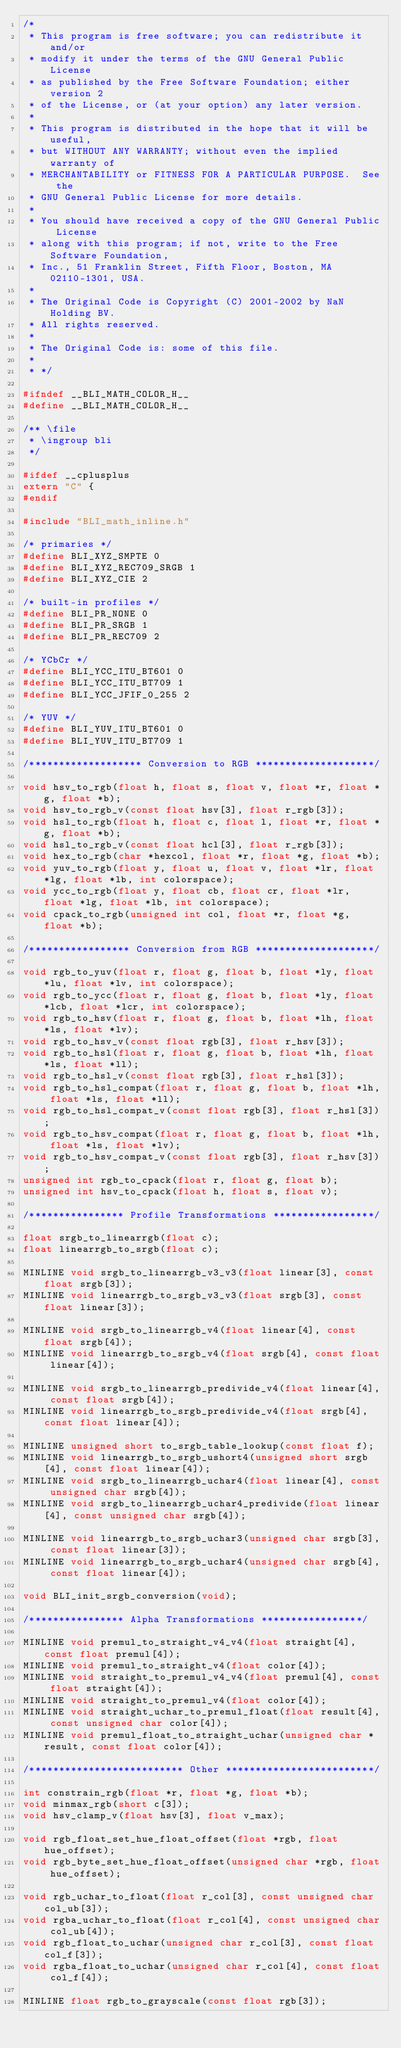Convert code to text. <code><loc_0><loc_0><loc_500><loc_500><_C_>/*
 * This program is free software; you can redistribute it and/or
 * modify it under the terms of the GNU General Public License
 * as published by the Free Software Foundation; either version 2
 * of the License, or (at your option) any later version.
 *
 * This program is distributed in the hope that it will be useful,
 * but WITHOUT ANY WARRANTY; without even the implied warranty of
 * MERCHANTABILITY or FITNESS FOR A PARTICULAR PURPOSE.  See the
 * GNU General Public License for more details.
 *
 * You should have received a copy of the GNU General Public License
 * along with this program; if not, write to the Free Software Foundation,
 * Inc., 51 Franklin Street, Fifth Floor, Boston, MA 02110-1301, USA.
 *
 * The Original Code is Copyright (C) 2001-2002 by NaN Holding BV.
 * All rights reserved.
 *
 * The Original Code is: some of this file.
 *
 * */

#ifndef __BLI_MATH_COLOR_H__
#define __BLI_MATH_COLOR_H__

/** \file
 * \ingroup bli
 */

#ifdef __cplusplus
extern "C" {
#endif

#include "BLI_math_inline.h"

/* primaries */
#define BLI_XYZ_SMPTE 0
#define BLI_XYZ_REC709_SRGB 1
#define BLI_XYZ_CIE 2

/* built-in profiles */
#define BLI_PR_NONE 0
#define BLI_PR_SRGB 1
#define BLI_PR_REC709 2

/* YCbCr */
#define BLI_YCC_ITU_BT601 0
#define BLI_YCC_ITU_BT709 1
#define BLI_YCC_JFIF_0_255 2

/* YUV */
#define BLI_YUV_ITU_BT601 0
#define BLI_YUV_ITU_BT709 1

/******************* Conversion to RGB ********************/

void hsv_to_rgb(float h, float s, float v, float *r, float *g, float *b);
void hsv_to_rgb_v(const float hsv[3], float r_rgb[3]);
void hsl_to_rgb(float h, float c, float l, float *r, float *g, float *b);
void hsl_to_rgb_v(const float hcl[3], float r_rgb[3]);
void hex_to_rgb(char *hexcol, float *r, float *g, float *b);
void yuv_to_rgb(float y, float u, float v, float *lr, float *lg, float *lb, int colorspace);
void ycc_to_rgb(float y, float cb, float cr, float *lr, float *lg, float *lb, int colorspace);
void cpack_to_rgb(unsigned int col, float *r, float *g, float *b);

/***************** Conversion from RGB ********************/

void rgb_to_yuv(float r, float g, float b, float *ly, float *lu, float *lv, int colorspace);
void rgb_to_ycc(float r, float g, float b, float *ly, float *lcb, float *lcr, int colorspace);
void rgb_to_hsv(float r, float g, float b, float *lh, float *ls, float *lv);
void rgb_to_hsv_v(const float rgb[3], float r_hsv[3]);
void rgb_to_hsl(float r, float g, float b, float *lh, float *ls, float *ll);
void rgb_to_hsl_v(const float rgb[3], float r_hsl[3]);
void rgb_to_hsl_compat(float r, float g, float b, float *lh, float *ls, float *ll);
void rgb_to_hsl_compat_v(const float rgb[3], float r_hsl[3]);
void rgb_to_hsv_compat(float r, float g, float b, float *lh, float *ls, float *lv);
void rgb_to_hsv_compat_v(const float rgb[3], float r_hsv[3]);
unsigned int rgb_to_cpack(float r, float g, float b);
unsigned int hsv_to_cpack(float h, float s, float v);

/**************** Profile Transformations *****************/

float srgb_to_linearrgb(float c);
float linearrgb_to_srgb(float c);

MINLINE void srgb_to_linearrgb_v3_v3(float linear[3], const float srgb[3]);
MINLINE void linearrgb_to_srgb_v3_v3(float srgb[3], const float linear[3]);

MINLINE void srgb_to_linearrgb_v4(float linear[4], const float srgb[4]);
MINLINE void linearrgb_to_srgb_v4(float srgb[4], const float linear[4]);

MINLINE void srgb_to_linearrgb_predivide_v4(float linear[4], const float srgb[4]);
MINLINE void linearrgb_to_srgb_predivide_v4(float srgb[4], const float linear[4]);

MINLINE unsigned short to_srgb_table_lookup(const float f);
MINLINE void linearrgb_to_srgb_ushort4(unsigned short srgb[4], const float linear[4]);
MINLINE void srgb_to_linearrgb_uchar4(float linear[4], const unsigned char srgb[4]);
MINLINE void srgb_to_linearrgb_uchar4_predivide(float linear[4], const unsigned char srgb[4]);

MINLINE void linearrgb_to_srgb_uchar3(unsigned char srgb[3], const float linear[3]);
MINLINE void linearrgb_to_srgb_uchar4(unsigned char srgb[4], const float linear[4]);

void BLI_init_srgb_conversion(void);

/**************** Alpha Transformations *****************/

MINLINE void premul_to_straight_v4_v4(float straight[4], const float premul[4]);
MINLINE void premul_to_straight_v4(float color[4]);
MINLINE void straight_to_premul_v4_v4(float premul[4], const float straight[4]);
MINLINE void straight_to_premul_v4(float color[4]);
MINLINE void straight_uchar_to_premul_float(float result[4], const unsigned char color[4]);
MINLINE void premul_float_to_straight_uchar(unsigned char *result, const float color[4]);

/************************** Other *************************/

int constrain_rgb(float *r, float *g, float *b);
void minmax_rgb(short c[3]);
void hsv_clamp_v(float hsv[3], float v_max);

void rgb_float_set_hue_float_offset(float *rgb, float hue_offset);
void rgb_byte_set_hue_float_offset(unsigned char *rgb, float hue_offset);

void rgb_uchar_to_float(float r_col[3], const unsigned char col_ub[3]);
void rgba_uchar_to_float(float r_col[4], const unsigned char col_ub[4]);
void rgb_float_to_uchar(unsigned char r_col[3], const float col_f[3]);
void rgba_float_to_uchar(unsigned char r_col[4], const float col_f[4]);

MINLINE float rgb_to_grayscale(const float rgb[3]);</code> 